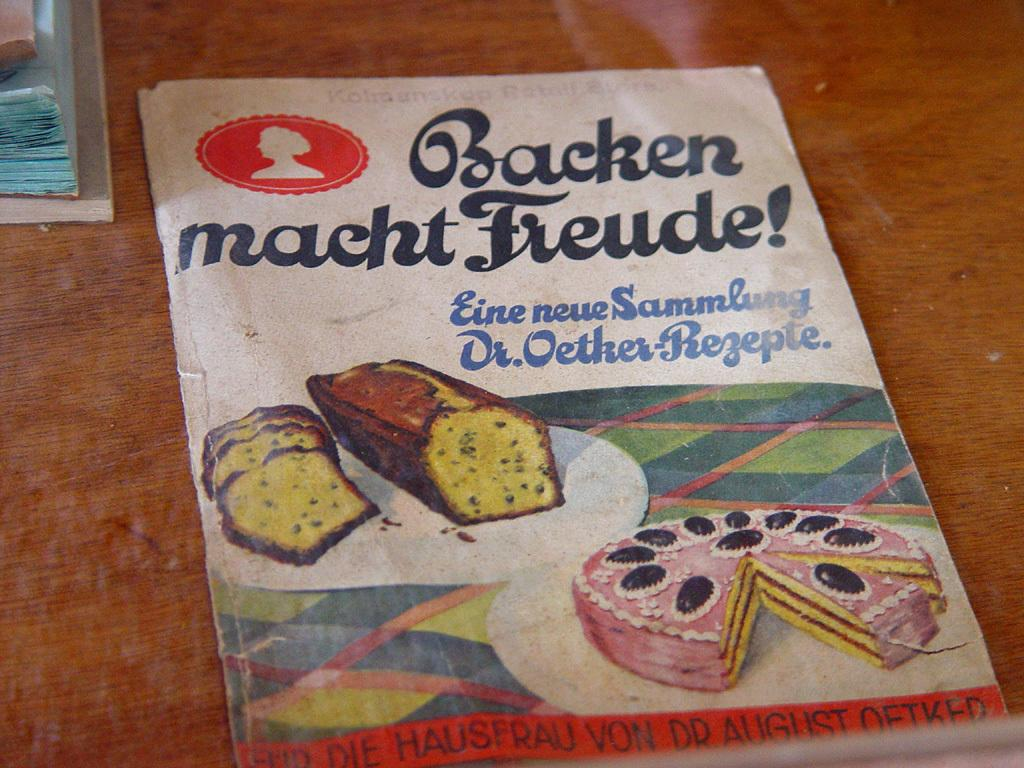What is present on the surface in the picture? There is a poster and bread on the surface. How is the poster connected to the surface? The poster is attached to the surface. Are there any words visible on the surface? Yes, there are words written on the surface. Can you see a frog hopping on the surface in the image? No, there is no frog present in the image. What type of transport is shown on the surface in the image? There is no transport depicted on the surface in the image. 